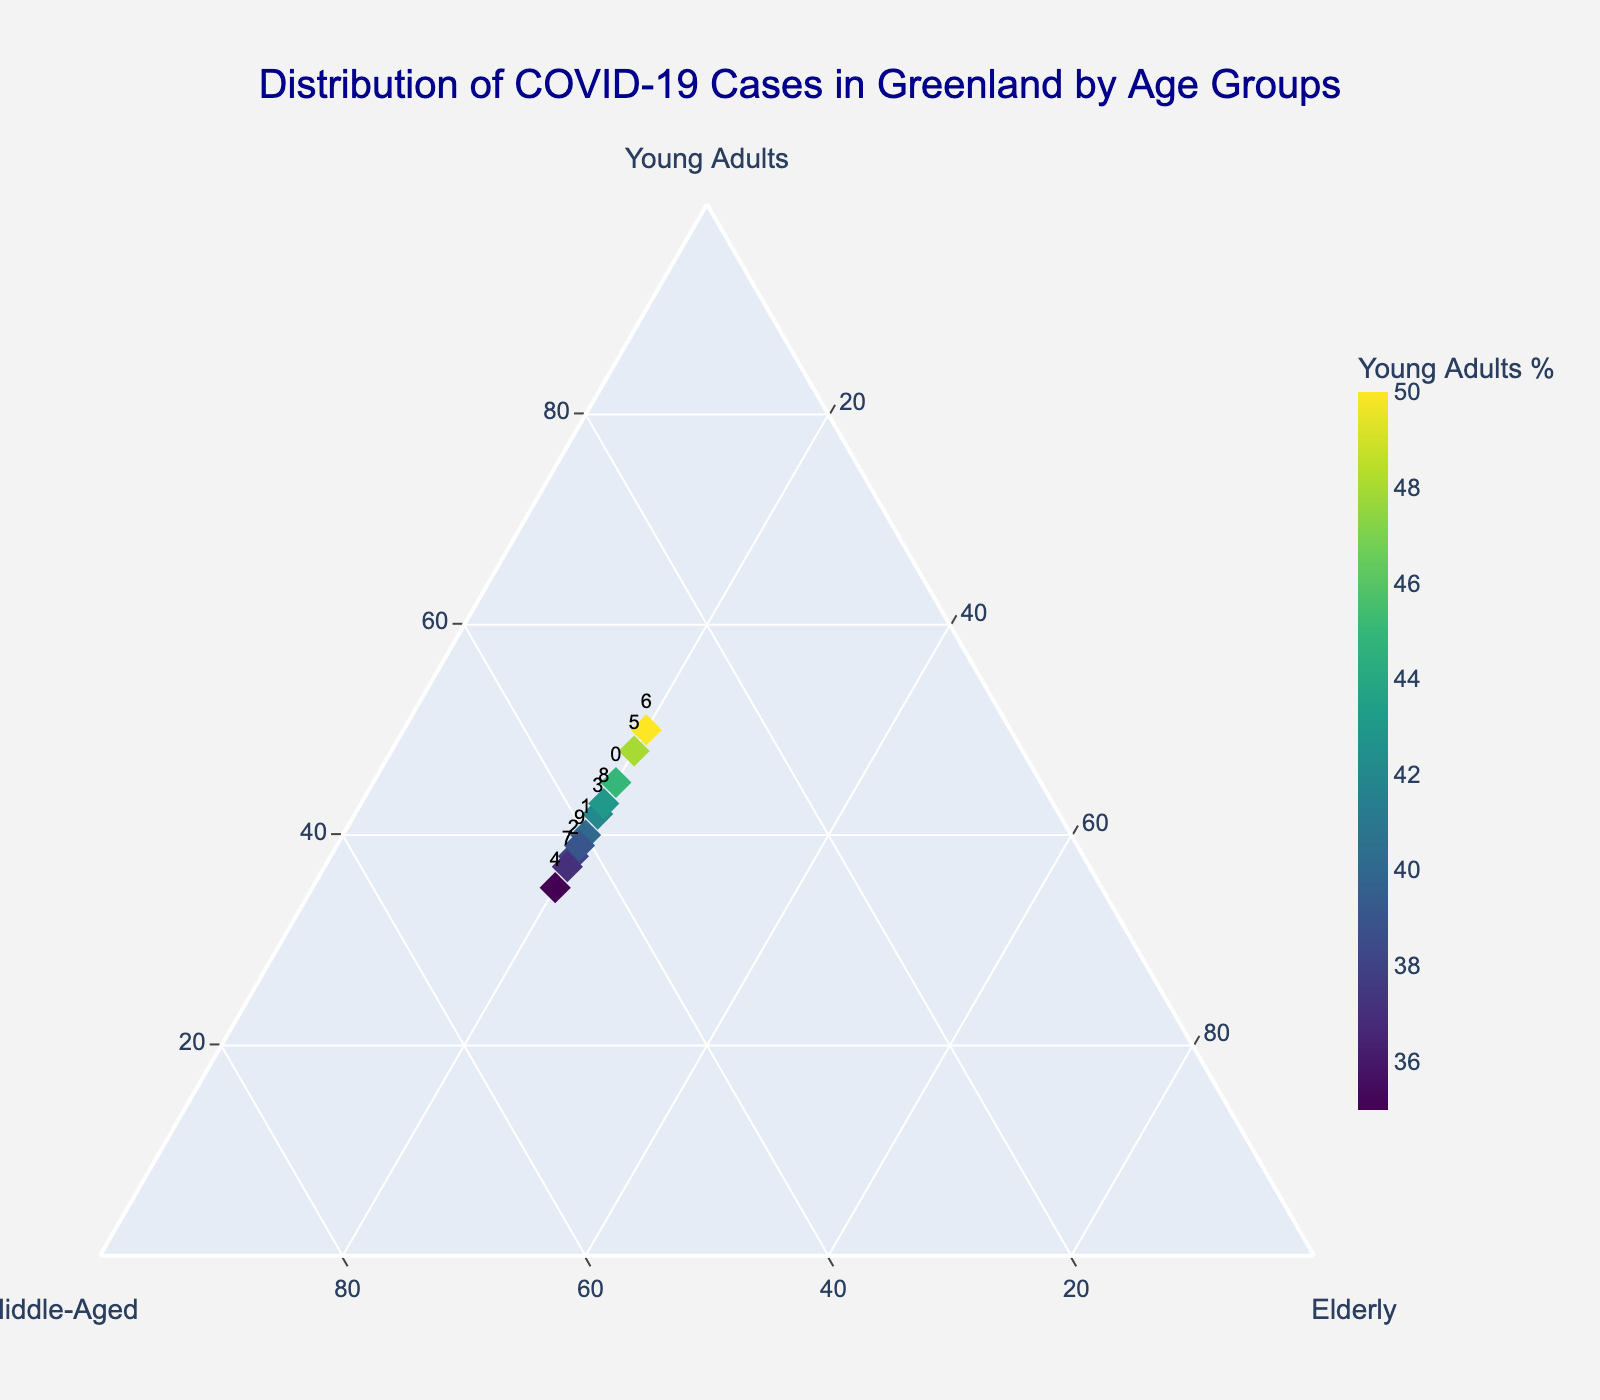What's the title of the figure? The title of the figure is displayed prominently at the top of the plot.
Answer: Distribution of COVID-19 Cases in Greenland by Age Groups How many age groups are shown in the ternary plot? By looking at the axis titles in the ternary plot, we can identify that there are three age groups.
Answer: Three Which city has the highest percentage of young adults? By observing the color intensity and the position closest to the Young Adults axis, we can identify the city. Tasiilaq has the highest value for Young Adults, marked by the darkest color.
Answer: Tasiilaq What is the composition of Nuuk in terms of COVID-19 cases by age group? By locating Nuuk on the plot and looking at the corresponding text labels, we can determine the percentages for each age group. Nuuk is plotted with 45% Young Adults, 35% Middle-Aged, and 20% Elderly.
Answer: Young Adults: 45%, Middle-Aged: 35%, Elderly: 20% Which two cities have the same percentage of elderly cases? By observing the plot, we notice that the 'Elderly' axis shows a uniform percentage for all cities. Every data point represents 20% Elderly cases, indicating that all cities share this percentage.
Answer: All cities Which city is most balanced in its distribution of middle-aged and young adult COVID-19 cases? By comparing cities' positions along the Middle-Aged and Young Adults axes, we look for cities with nearly equal values. Sisimiut, with 40% Middle-Aged and 40% Young Adults, is the most balanced.
Answer: Sisimiut Which city has the smallest percentage of middle-aged COVID-19 cases? Looking at the closest points to the Middle-Aged axis, Tasiilaq has the smallest value of 30%.
Answer: Tasiilaq What is the difference in the percentage of young adults between Maniitsoq and Aasiaat? By finding the values for young adults in both cities (Maniitsoq: 48%, Aasiaat: 35%), we can calculate the difference: 48 - 35 = 13%.
Answer: 13% How does the young adult percentage in Qaqortoq compare to Nanortalik? By comparing the young adult percentages (Qaqortoq: 42%, Nanortalik: 39%), we see that Qaqortoq has a slightly higher percentage.
Answer: Qaqortoq has a higher percentage Does any city have the same distribution for middle-aged and elderly groups? Observing the plot, we can see that no city has identical values for middle-aged and elderly groups according to their positions on the ternary plot. Each data point indicates unique values even though the Elderly percentage is constant at 20%.
Answer: No 